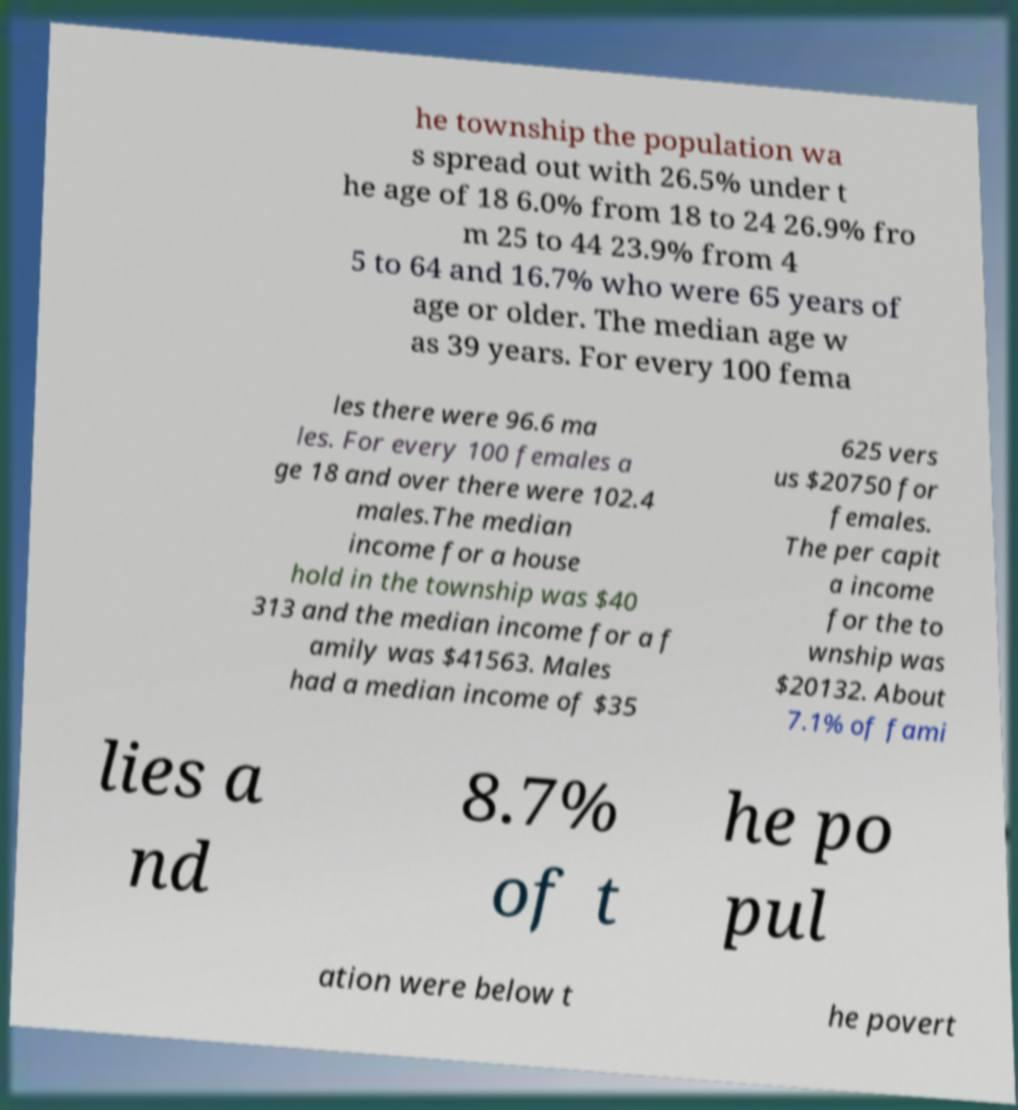Please identify and transcribe the text found in this image. he township the population wa s spread out with 26.5% under t he age of 18 6.0% from 18 to 24 26.9% fro m 25 to 44 23.9% from 4 5 to 64 and 16.7% who were 65 years of age or older. The median age w as 39 years. For every 100 fema les there were 96.6 ma les. For every 100 females a ge 18 and over there were 102.4 males.The median income for a house hold in the township was $40 313 and the median income for a f amily was $41563. Males had a median income of $35 625 vers us $20750 for females. The per capit a income for the to wnship was $20132. About 7.1% of fami lies a nd 8.7% of t he po pul ation were below t he povert 